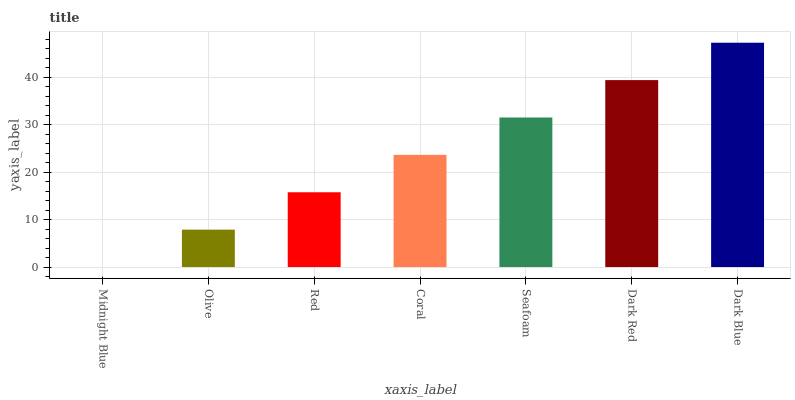Is Olive the minimum?
Answer yes or no. No. Is Olive the maximum?
Answer yes or no. No. Is Olive greater than Midnight Blue?
Answer yes or no. Yes. Is Midnight Blue less than Olive?
Answer yes or no. Yes. Is Midnight Blue greater than Olive?
Answer yes or no. No. Is Olive less than Midnight Blue?
Answer yes or no. No. Is Coral the high median?
Answer yes or no. Yes. Is Coral the low median?
Answer yes or no. Yes. Is Red the high median?
Answer yes or no. No. Is Red the low median?
Answer yes or no. No. 